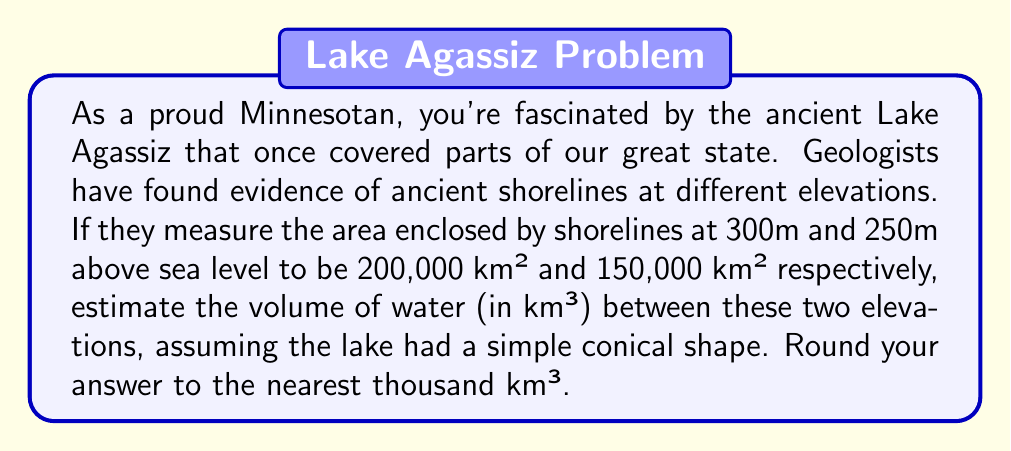Can you solve this math problem? Let's approach this step-by-step, using the formula for the volume of a truncated cone:

1) The formula for the volume of a truncated cone is:
   $$V = \frac{1}{3}\pi h(R^2 + r^2 + Rr)$$
   where $h$ is the height, $R$ is the radius of the lower base, and $r$ is the radius of the upper base.

2) We need to find $R$ and $r$. We can do this using the area formula for a circle:
   $$A = \pi r^2$$

3) For the lower shoreline (300m):
   $$150,000 = \pi R^2$$
   $$R = \sqrt{\frac{150,000}{\pi}} \approx 218.7 \text{ km}$$

4) For the upper shoreline (250m):
   $$200,000 = \pi r^2$$
   $$r = \sqrt{\frac{200,000}{\pi}} \approx 252.3 \text{ km}$$

5) The height $h$ is the difference in elevation: 300m - 250m = 50m = 0.05 km

6) Now we can plug these values into our volume formula:
   $$V = \frac{1}{3}\pi (0.05)(218.7^2 + 252.3^2 + 218.7 \cdot 252.3)$$

7) Calculating this:
   $$V \approx 8,786 \text{ km}^3$$

8) Rounding to the nearest thousand:
   $$V \approx 9,000 \text{ km}^3$$
Answer: 9,000 km³ 